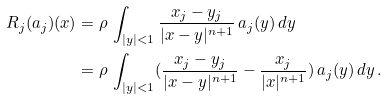Convert formula to latex. <formula><loc_0><loc_0><loc_500><loc_500>R _ { j } ( a _ { j } ) ( x ) & = \rho \, \int _ { | y | < 1 } \frac { x _ { j } - y _ { j } } { | x - y | ^ { n + 1 } } \, a _ { j } ( y ) \, d y \\ & = \rho \, \int _ { | y | < 1 } ( \frac { x _ { j } - y _ { j } } { | x - y | ^ { n + 1 } } - \frac { x _ { j } } { | x | ^ { n + 1 } } ) \, a _ { j } ( y ) \, d y \, .</formula> 